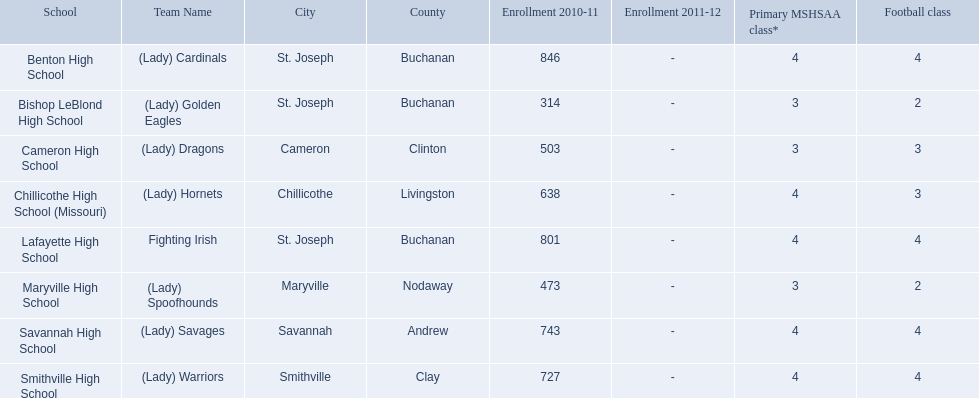What were the schools enrolled in 2010-2011 Benton High School, Bishop LeBlond High School, Cameron High School, Chillicothe High School (Missouri), Lafayette High School, Maryville High School, Savannah High School, Smithville High School. How many were enrolled in each? 846, 314, 503, 638, 801, 473, 743, 727. Which is the lowest number? 314. Which school had this number of students? Bishop LeBlond High School. 